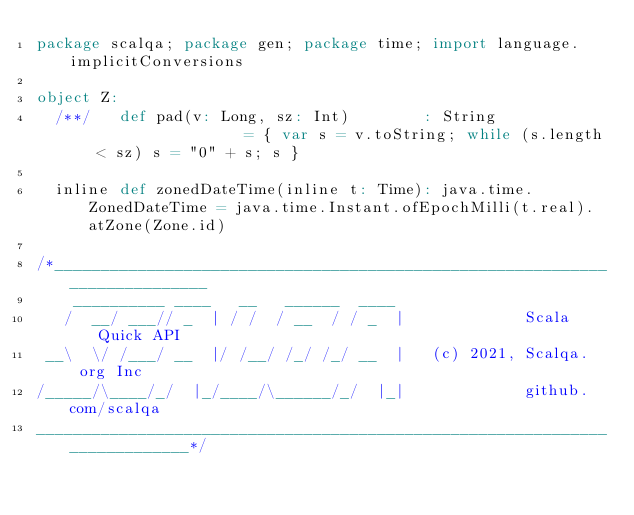Convert code to text. <code><loc_0><loc_0><loc_500><loc_500><_Scala_>package scalqa; package gen; package time; import language.implicitConversions

object Z:
  /**/   def pad(v: Long, sz: Int)        : String                  = { var s = v.toString; while (s.length < sz) s = "0" + s; s }

  inline def zonedDateTime(inline t: Time): java.time.ZonedDateTime = java.time.Instant.ofEpochMilli(t.real).atZone(Zone.id)

/*___________________________________________________________________________
    __________ ____   __   ______  ____
   /  __/ ___// _  | / /  / __  / / _  |             Scala Quick API
 __\  \/ /___/ __  |/ /__/ /_/ /_/ __  |   (c) 2021, Scalqa.org Inc
/_____/\____/_/  |_/____/\______/_/  |_|             github.com/scalqa
___________________________________________________________________________*/
</code> 